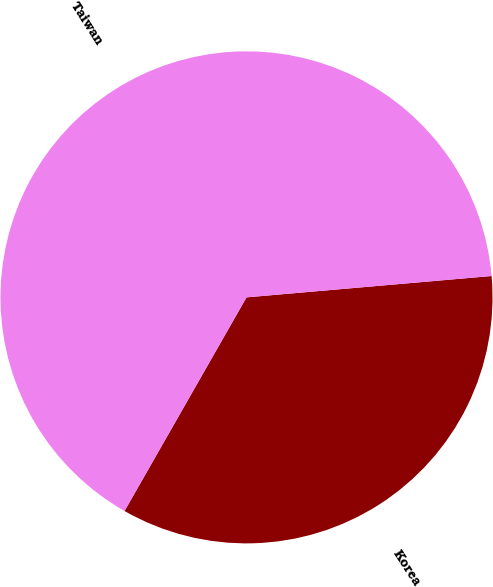<chart> <loc_0><loc_0><loc_500><loc_500><pie_chart><fcel>Korea<fcel>Taiwan<nl><fcel>34.64%<fcel>65.36%<nl></chart> 